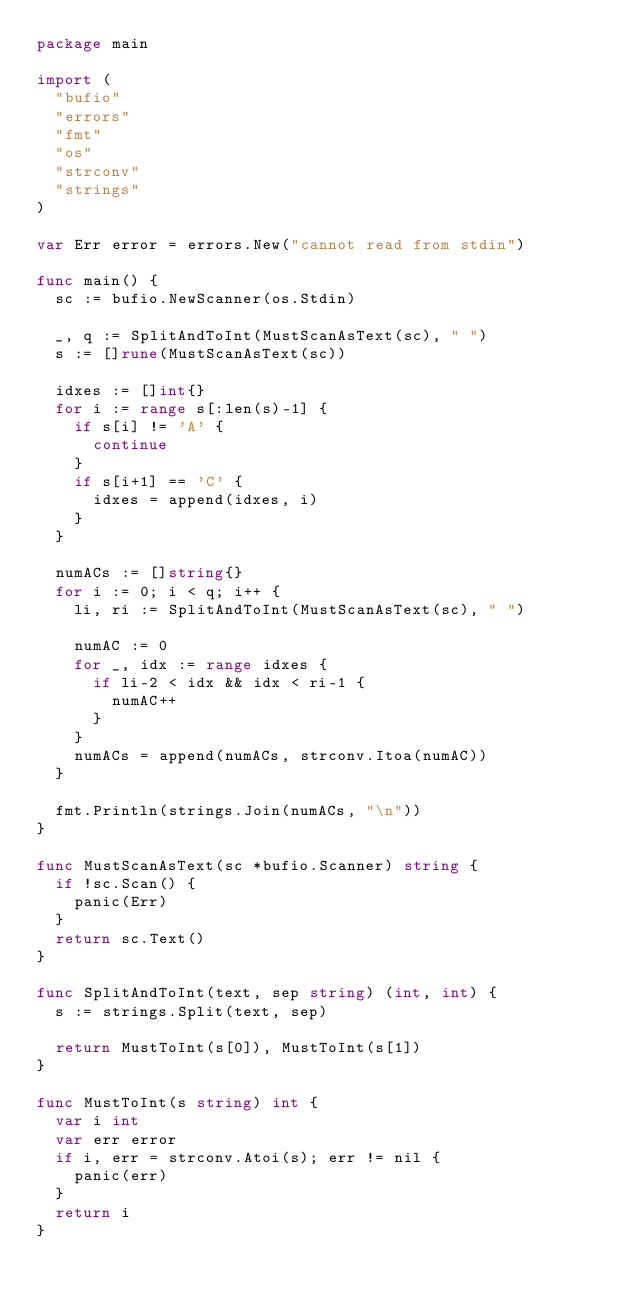<code> <loc_0><loc_0><loc_500><loc_500><_Go_>package main

import (
	"bufio"
	"errors"
	"fmt"
	"os"
	"strconv"
	"strings"
)

var Err error = errors.New("cannot read from stdin")

func main() {
	sc := bufio.NewScanner(os.Stdin)

	_, q := SplitAndToInt(MustScanAsText(sc), " ")
	s := []rune(MustScanAsText(sc))

	idxes := []int{}
	for i := range s[:len(s)-1] {
		if s[i] != 'A' {
			continue
		}
		if s[i+1] == 'C' {
			idxes = append(idxes, i)
		}
	}

	numACs := []string{}
	for i := 0; i < q; i++ {
		li, ri := SplitAndToInt(MustScanAsText(sc), " ")

		numAC := 0
		for _, idx := range idxes {
			if li-2 < idx && idx < ri-1 {
				numAC++
			}
		}
		numACs = append(numACs, strconv.Itoa(numAC))
	}

	fmt.Println(strings.Join(numACs, "\n"))
}

func MustScanAsText(sc *bufio.Scanner) string {
	if !sc.Scan() {
		panic(Err)
	}
	return sc.Text()
}

func SplitAndToInt(text, sep string) (int, int) {
	s := strings.Split(text, sep)

	return MustToInt(s[0]), MustToInt(s[1])
}

func MustToInt(s string) int {
	var i int
	var err error
	if i, err = strconv.Atoi(s); err != nil {
		panic(err)
	}
	return i
}</code> 